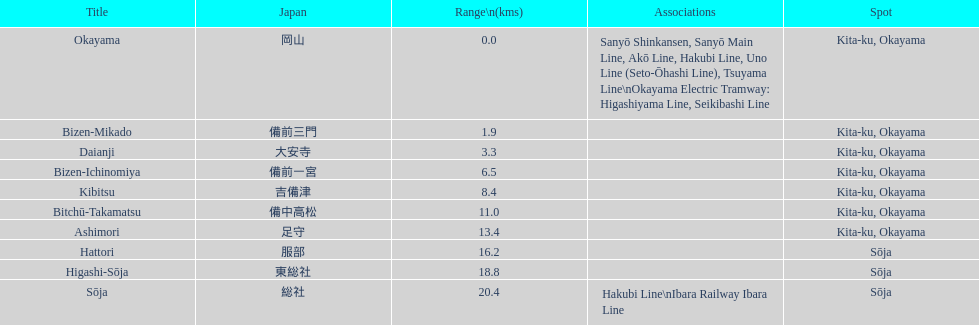How many consecutive stops must you travel through is you board the kibi line at bizen-mikado at depart at kibitsu? 2. 